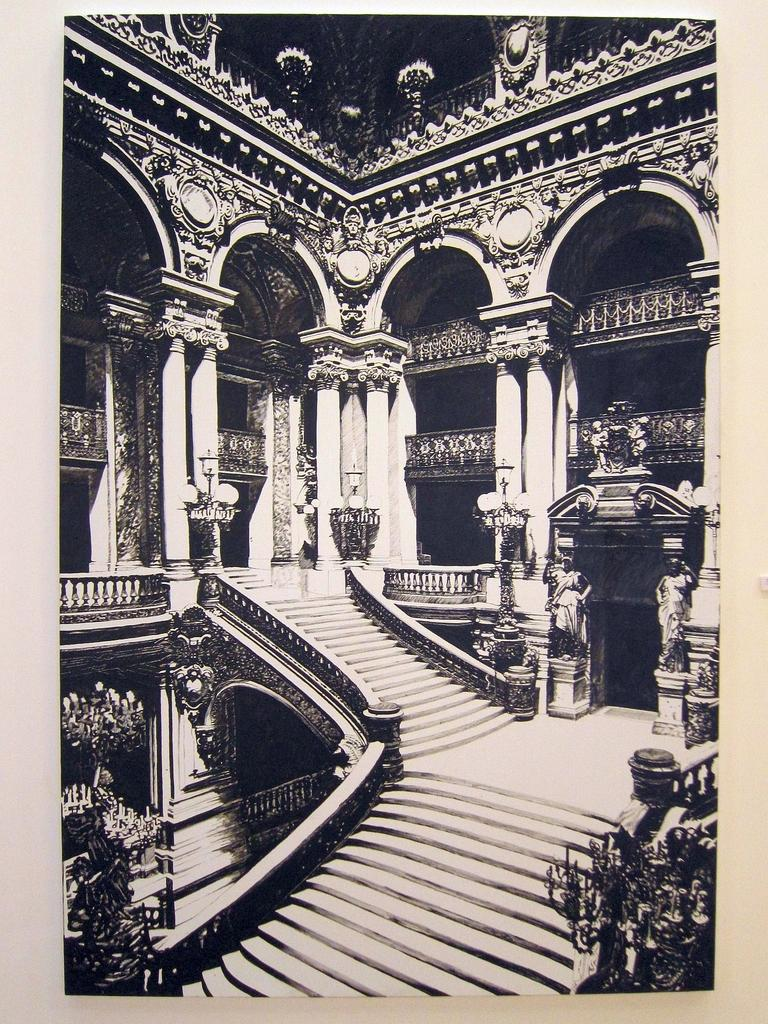What is the color scheme of the image? The image is black and white. What can be seen in the image? There is a staircase in the image. Where is the staircase located? The staircase is inside a fort. What type of skirt is being worn by the toes in the image? There are no toes or skirts present in the image, as it is a black and white image of a staircase inside a fort. 